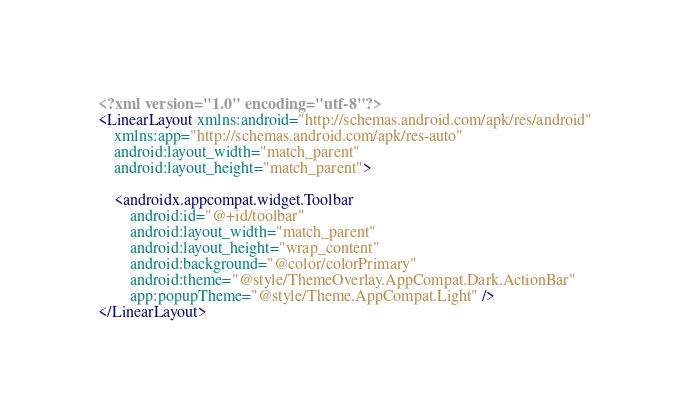Convert code to text. <code><loc_0><loc_0><loc_500><loc_500><_XML_><?xml version="1.0" encoding="utf-8"?>
<LinearLayout xmlns:android="http://schemas.android.com/apk/res/android"
    xmlns:app="http://schemas.android.com/apk/res-auto"
    android:layout_width="match_parent"
    android:layout_height="match_parent">

    <androidx.appcompat.widget.Toolbar
        android:id="@+id/toolbar"
        android:layout_width="match_parent"
        android:layout_height="wrap_content"
        android:background="@color/colorPrimary"
        android:theme="@style/ThemeOverlay.AppCompat.Dark.ActionBar"
        app:popupTheme="@style/Theme.AppCompat.Light" />
</LinearLayout></code> 